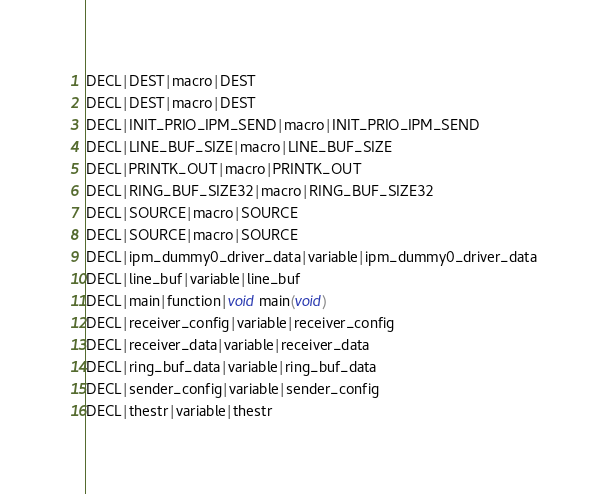Convert code to text. <code><loc_0><loc_0><loc_500><loc_500><_C_>DECL|DEST|macro|DEST
DECL|DEST|macro|DEST
DECL|INIT_PRIO_IPM_SEND|macro|INIT_PRIO_IPM_SEND
DECL|LINE_BUF_SIZE|macro|LINE_BUF_SIZE
DECL|PRINTK_OUT|macro|PRINTK_OUT
DECL|RING_BUF_SIZE32|macro|RING_BUF_SIZE32
DECL|SOURCE|macro|SOURCE
DECL|SOURCE|macro|SOURCE
DECL|ipm_dummy0_driver_data|variable|ipm_dummy0_driver_data
DECL|line_buf|variable|line_buf
DECL|main|function|void main(void)
DECL|receiver_config|variable|receiver_config
DECL|receiver_data|variable|receiver_data
DECL|ring_buf_data|variable|ring_buf_data
DECL|sender_config|variable|sender_config
DECL|thestr|variable|thestr
</code> 